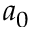Convert formula to latex. <formula><loc_0><loc_0><loc_500><loc_500>a _ { 0 }</formula> 